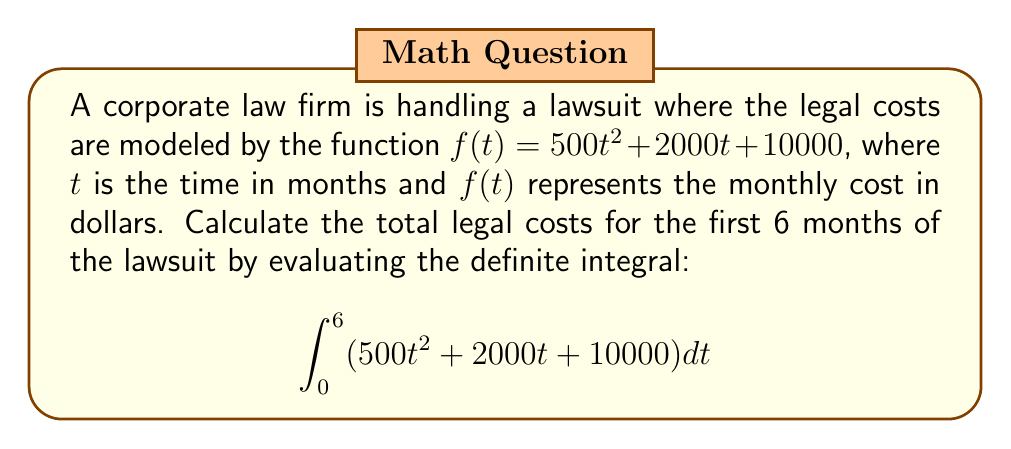Teach me how to tackle this problem. To solve this problem, we need to integrate the given function and evaluate it over the specified interval. Let's break it down step-by-step:

1) First, let's integrate each term of the function:

   $\int (500t^2 + 2000t + 10000) dt$
   
   $= \frac{500t^3}{3} + 1000t^2 + 10000t + C$

2) Now, we need to evaluate this integral from 0 to 6:

   $[\frac{500t^3}{3} + 1000t^2 + 10000t]_0^6$

3) Let's substitute the upper and lower bounds:

   $(\frac{500(6)^3}{3} + 1000(6)^2 + 10000(6)) - (\frac{500(0)^3}{3} + 1000(0)^2 + 10000(0))$

4) Simplify:

   $(\frac{500(216)}{3} + 1000(36) + 60000) - (0)$
   
   $= 36000 + 36000 + 60000$
   
   $= 132000$

Therefore, the total legal costs for the first 6 months of the lawsuit are $132,000.
Answer: $132,000 